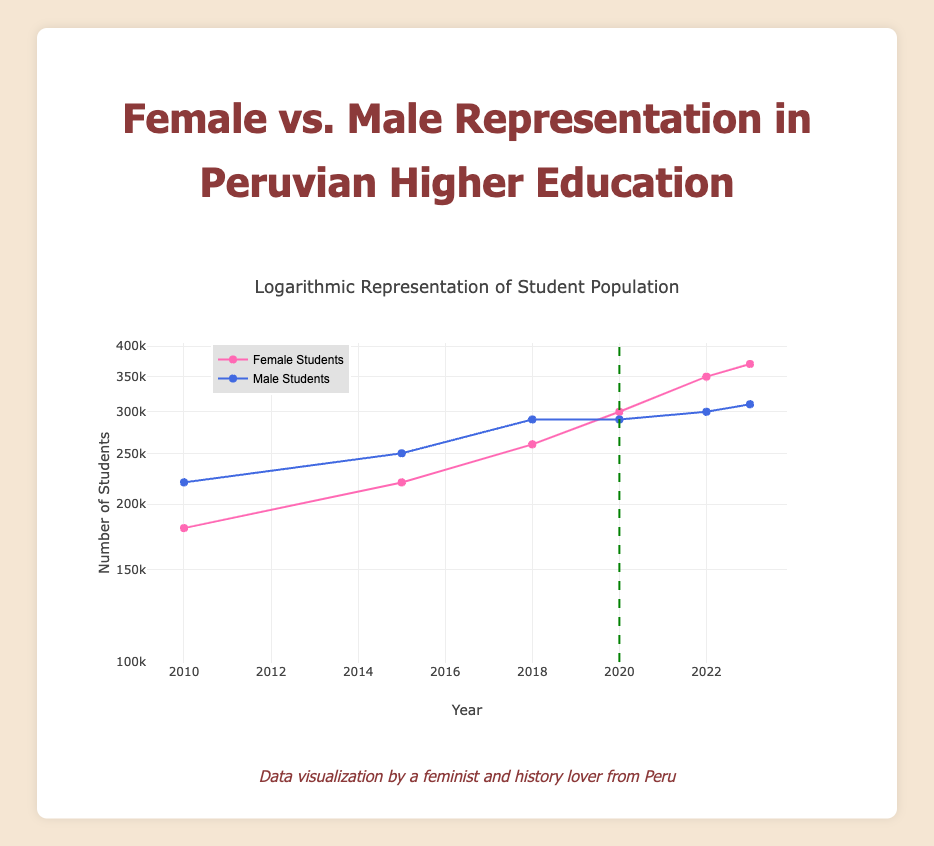What was the number of female students in 2022? The table shows that in 2022, the female students' count is explicitly listed as 350,000.
Answer: 350000 What year did female student representation surpass male student representation? Looking at the years recorded, in 2020, there were 300,000 female students and 290,000 male students, indicating that female representation surpassed male representation that year.
Answer: 2020 What is the difference in the number of male and female students in 2023? In 2023, there are 370,000 female students and 310,000 male students. To find the difference, we subtract 310,000 from 370,000, resulting in 60,000.
Answer: 60000 Was there a year when male student representation was lower than female student representation? The data shows that in 2020, the number of male students was lower than female students (290,000 compared to 300,000), confirming that this occurred that year.
Answer: Yes What is the total number of students (both male and female) in 2020? In 2020, there were 300,000 female students and 290,000 male students. Adding these together gives a total of 590,000 students.
Answer: 590000 In which year did the number of female students increase by the largest margin from the previous year? By comparing the number of female students from year to year, the largest increase occurred between 2021 and 2022 with an increase from 300,000 to 350,000, which is a 50,000 increase.
Answer: 2022 What was the average number of male students from 2010 to 2023? Adding the male student numbers from each year (220,000 + 250,000 + 290,000 + 290,000 + 300,000 + 310,000) gives 1,660,000. Dividing this by 6 years provides an average of 276,667.
Answer: 276667 True or False: The number of male students has decreased every year after 2018. The table shows that the number of male students actually increased from 290,000 in 2018 to 300,000 in 2022 and to 310,000 in 2023, indicating a false statement.
Answer: False 